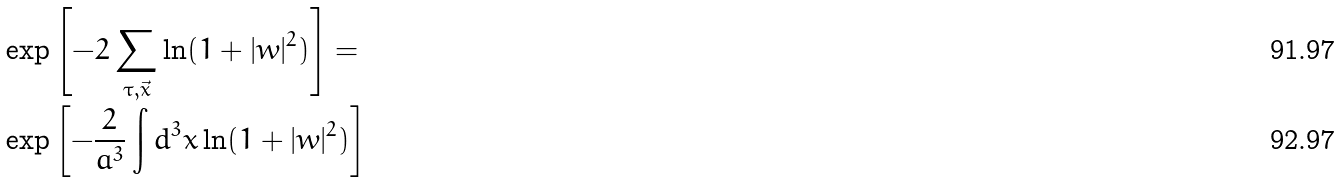<formula> <loc_0><loc_0><loc_500><loc_500>& \exp { \left [ - 2 \sum _ { \tau , \vec { x } } \ln ( 1 + | w | ^ { 2 } ) \right ] } = \\ & \exp { \left [ - \frac { 2 } { a ^ { 3 } } \int d ^ { 3 } x \ln ( 1 + | w | ^ { 2 } ) \right ] }</formula> 